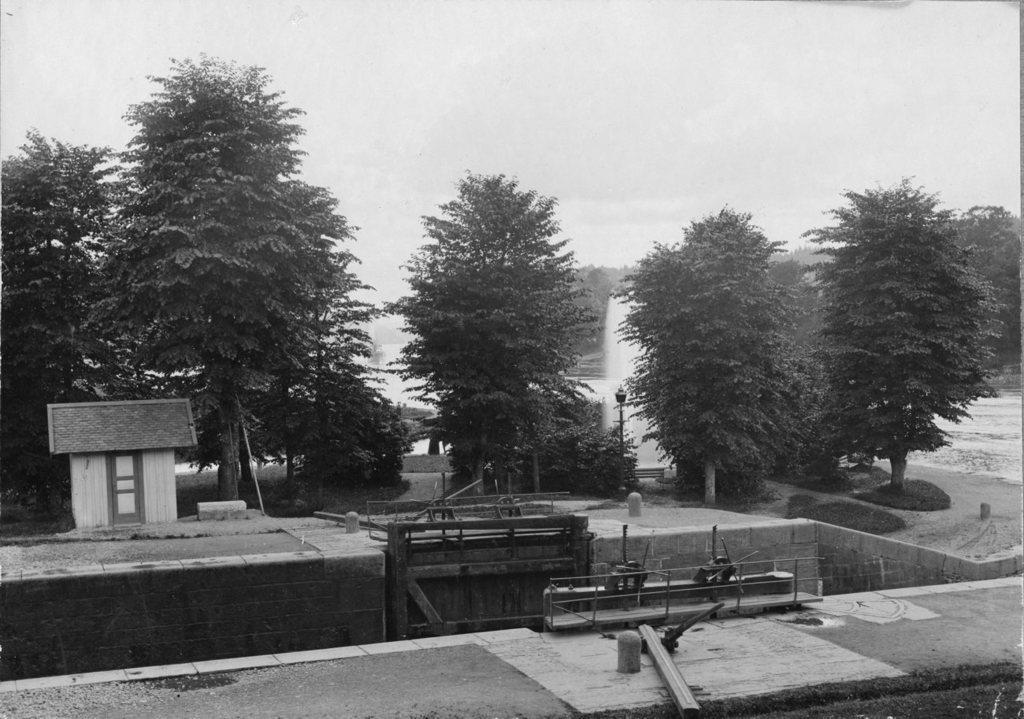Describe this image in one or two sentences. In this image we can see two roads, at the back there are trees, there is a pole, there is a water fountain, there it is in black and white, there is a sky. 